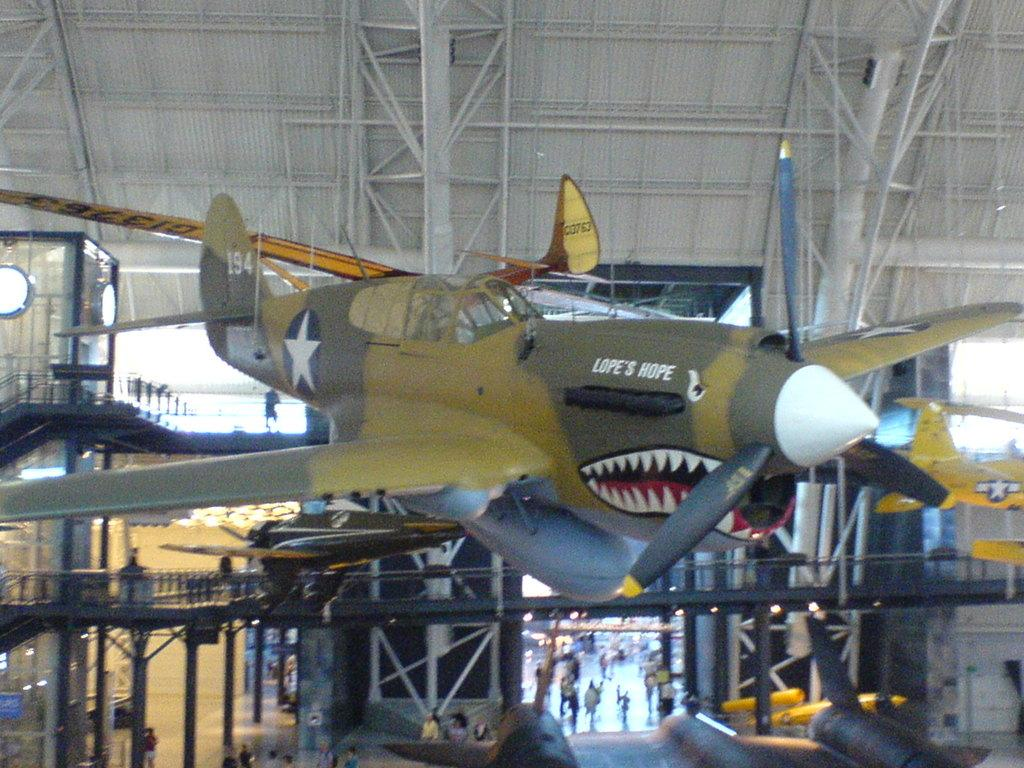<image>
Provide a brief description of the given image. The airplane named "Lope's Hope" is suspended in air in a hangar. 